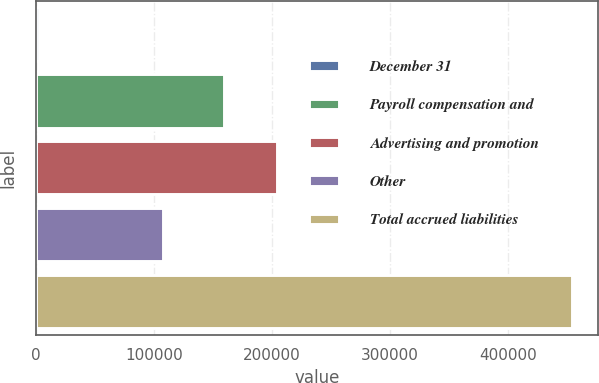<chart> <loc_0><loc_0><loc_500><loc_500><bar_chart><fcel>December 31<fcel>Payroll compensation and<fcel>Advertising and promotion<fcel>Other<fcel>Total accrued liabilities<nl><fcel>2006<fcel>158952<fcel>204154<fcel>107577<fcel>454023<nl></chart> 